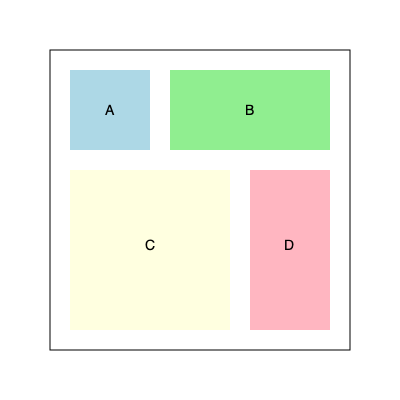Given a square warehouse of side length 300 units, you need to optimize the arrangement of four rectangular storage areas (A, B, C, and D) with the following dimensions:

A: 80 x 80
B: 160 x 80
C: 160 x 160
D: 80 x 160

What is the minimum area (in square units) of unused space in the warehouse after arranging these storage areas optimally? To solve this problem, we'll follow these steps:

1) First, calculate the total area of the warehouse:
   Area of warehouse = $300 \times 300 = 90,000$ square units

2) Calculate the total area of all storage spaces:
   A: $80 \times 80 = 6,400$ sq units
   B: $160 \times 80 = 12,800$ sq units
   C: $160 \times 160 = 25,600$ sq units
   D: $80 \times 160 = 12,800$ sq units
   Total storage area = $6,400 + 12,800 + 25,600 + 12,800 = 57,600$ sq units

3) The optimal arrangement is shown in the diagram, where:
   - A is placed in the top-left corner
   - B is placed to the right of A
   - C is placed below A and B
   - D is placed to the right of C

4) This arrangement leaves two strips of unused space:
   - A strip of width 20 units on the right side (300 - 280 = 20)
   - A strip of height 20 units at the bottom (300 - 280 = 20)

5) Calculate the area of unused space:
   Right strip: $20 \times 300 = 6,000$ sq units
   Bottom strip: $280 \times 20 = 5,600$ sq units
   Total unused space = $6,000 + 5,600 = 11,600$ sq units

6) Verify:
   Used space + Unused space = $57,600 + 11,600 = 69,200$ sq units
   This equals the total warehouse area of 90,000 sq units

Therefore, the minimum area of unused space is 11,600 square units.
Answer: 11,600 square units 